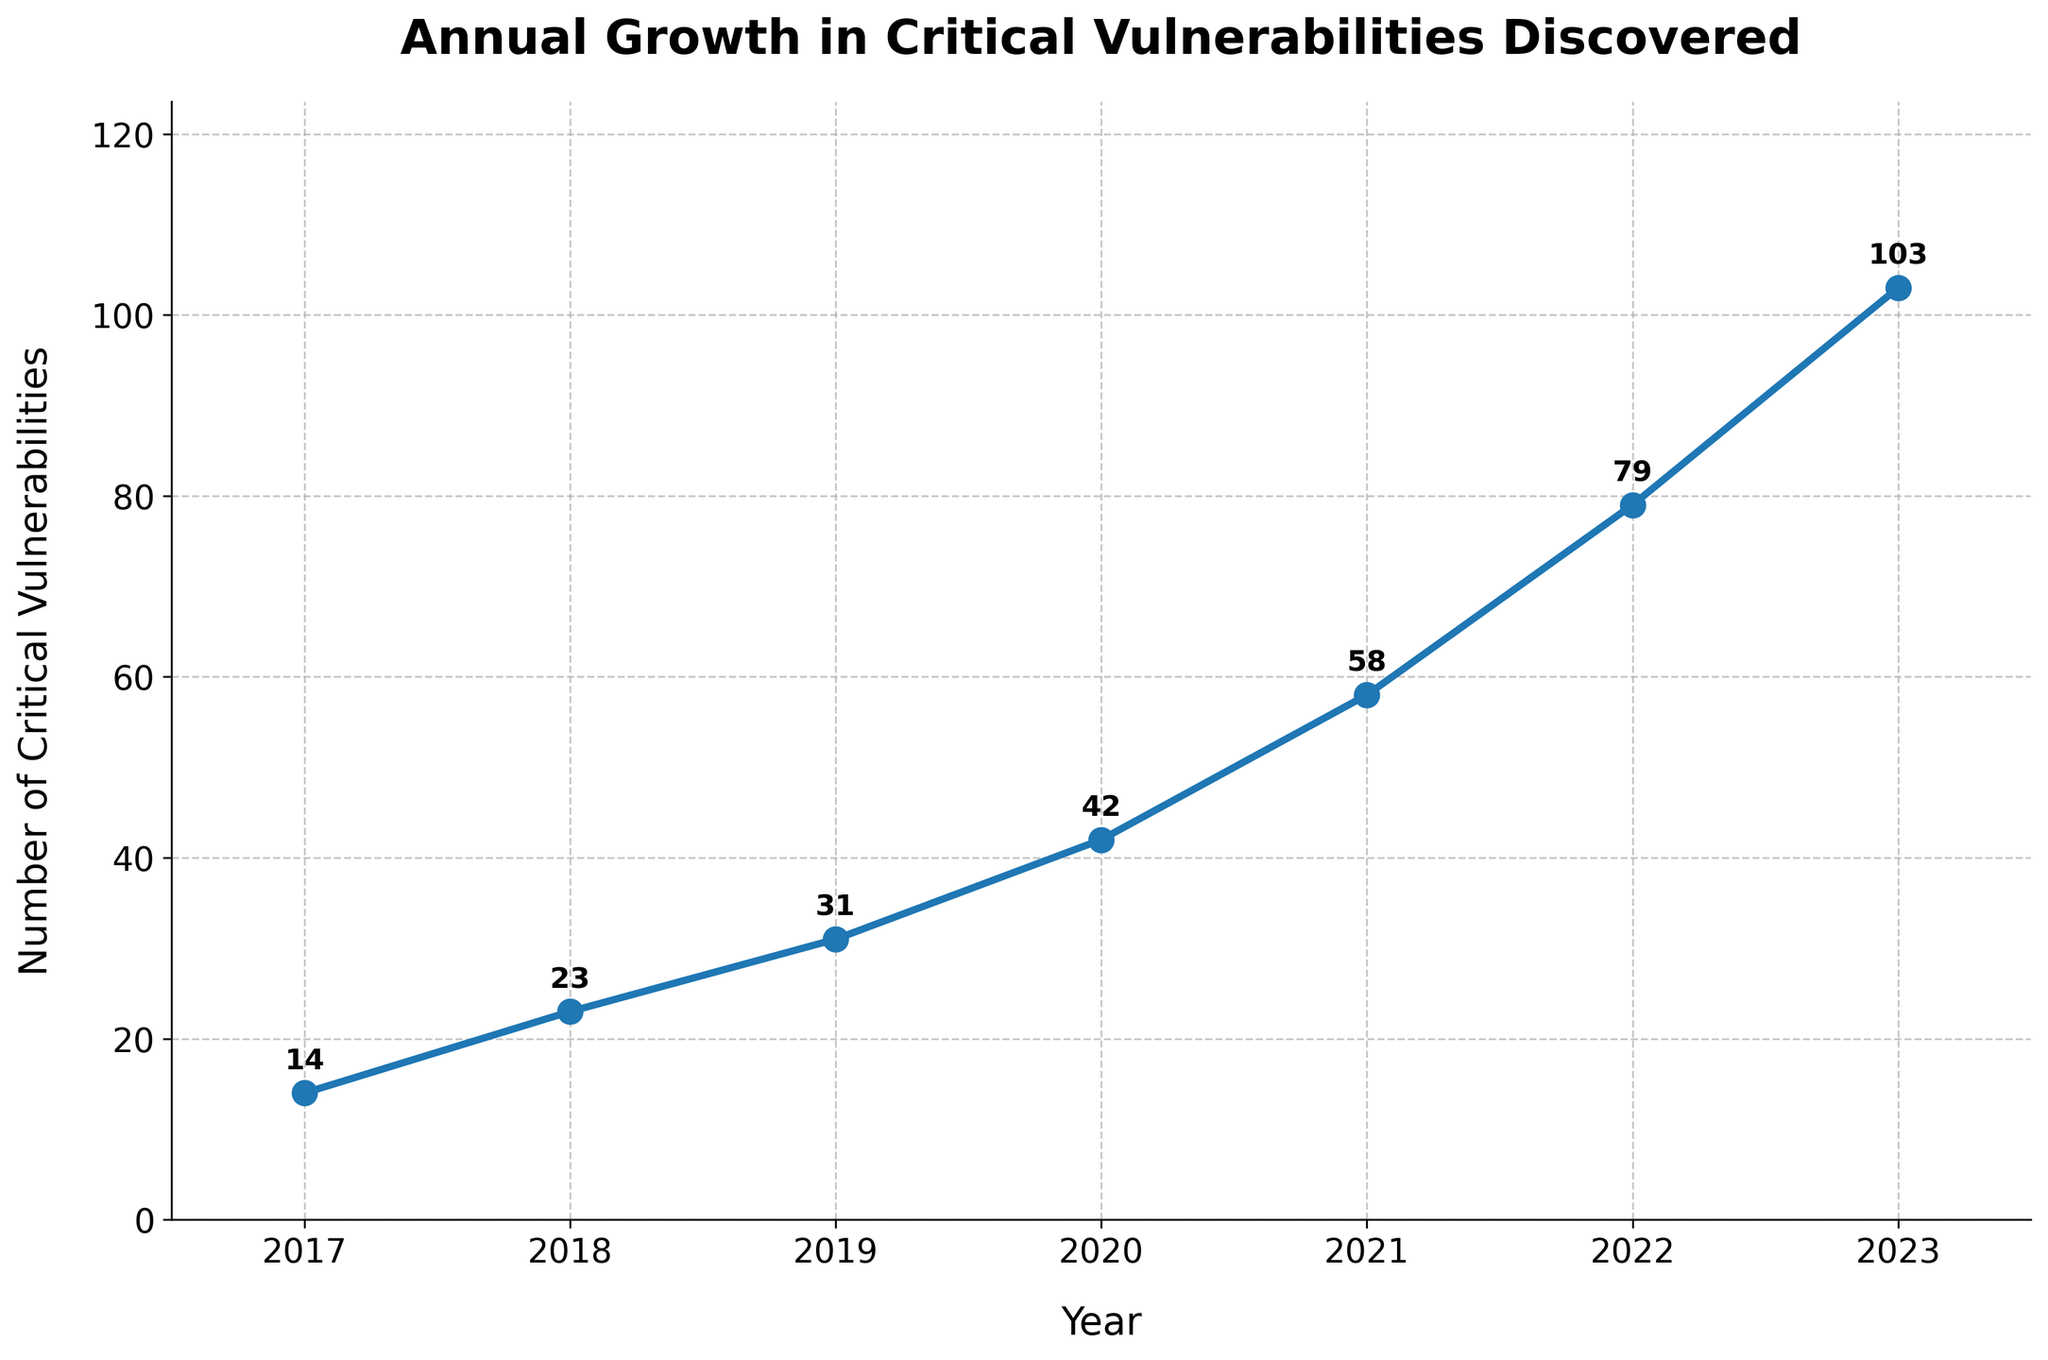What's the average number of critical vulnerabilities discovered per year? To calculate the average, sum all the vulnerabilities discovered from 2017 to 2023 and then divide by the number of years (which is 7). The sum is 14 + 23 + 31 + 42 + 58 + 79 + 103 = 350. So the average is 350/7 = 50.
Answer: 50 In which year was the largest increase in critical vulnerabilities discovered compared to the previous year? Compute the difference between each consecutive year. The differences are 23-14=9, 31-23=8, 42-31=11, 58-42=16, 79-58=21, and 103-79=24. The largest increase is 24, which occurred from 2022 to 2023.
Answer: 2023 How many more critical vulnerabilities were discovered in 2021 compared to 2019? Subtract the number of vulnerabilities in 2019 from that in 2021. That is, 58 - 31 = 27.
Answer: 27 On average, how many additional critical vulnerabilities were discovered per year from 2017 to 2023? Find the total difference from 2017 to 2023, which is 103 - 14 = 89. Then divide by the number of intervals (years - 1), which is 89 / (7 - 1) = 14.83 (approx).
Answer: 14.83 Which year had the lowest number of critical vulnerabilities discovered? Refer to the chart and find the year with the lowest data point. 2017 had the lowest number with 14 vulnerabilities.
Answer: 2017 How did the number of critical vulnerabilities discovered in 2018 compare to that in 2020? Subtract the number in 2018 from that in 2020. That is, 42 - 23 = 19.
Answer: 19 What's the cumulative number of critical vulnerabilities discovered by the end of 2021? Add the number of vulnerabilities discovered each year up to and including 2021. That is 14 + 23 + 31 + 42 + 58 = 168.
Answer: 168 